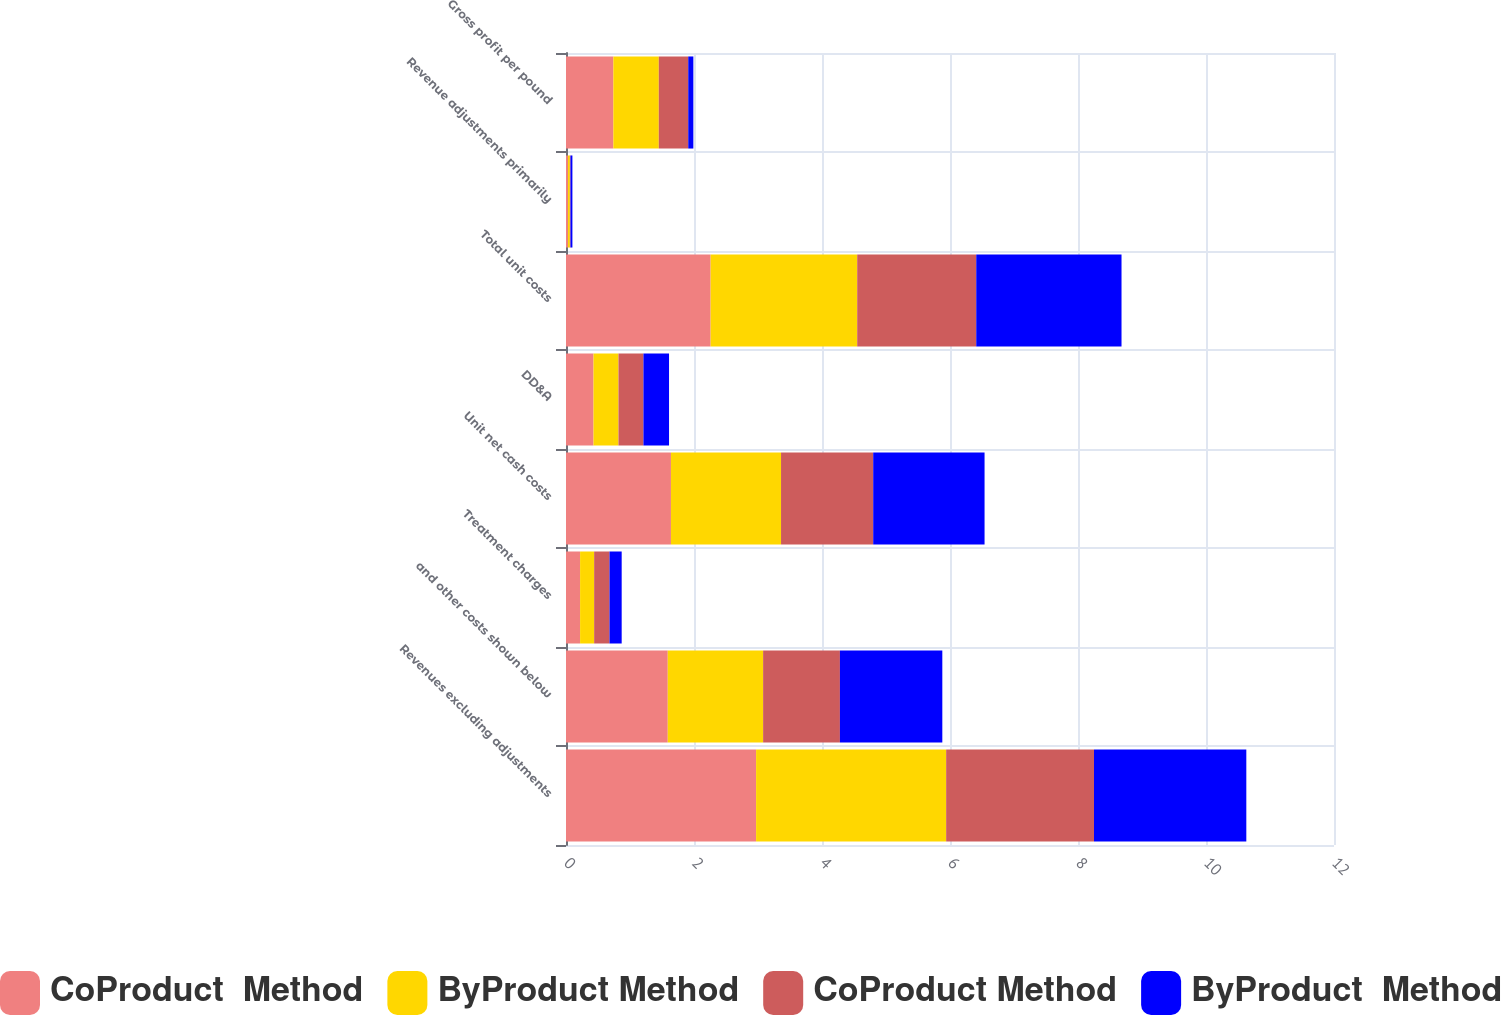<chart> <loc_0><loc_0><loc_500><loc_500><stacked_bar_chart><ecel><fcel>Revenues excluding adjustments<fcel>and other costs shown below<fcel>Treatment charges<fcel>Unit net cash costs<fcel>DD&A<fcel>Total unit costs<fcel>Revenue adjustments primarily<fcel>Gross profit per pound<nl><fcel>CoProduct  Method<fcel>2.97<fcel>1.59<fcel>0.22<fcel>1.64<fcel>0.43<fcel>2.26<fcel>0.03<fcel>0.74<nl><fcel>ByProduct Method<fcel>2.97<fcel>1.49<fcel>0.22<fcel>1.72<fcel>0.39<fcel>2.29<fcel>0.03<fcel>0.71<nl><fcel>CoProduct Method<fcel>2.31<fcel>1.2<fcel>0.24<fcel>1.44<fcel>0.39<fcel>1.86<fcel>0.01<fcel>0.46<nl><fcel>ByProduct  Method<fcel>2.38<fcel>1.6<fcel>0.19<fcel>1.74<fcel>0.4<fcel>2.27<fcel>0.03<fcel>0.08<nl></chart> 